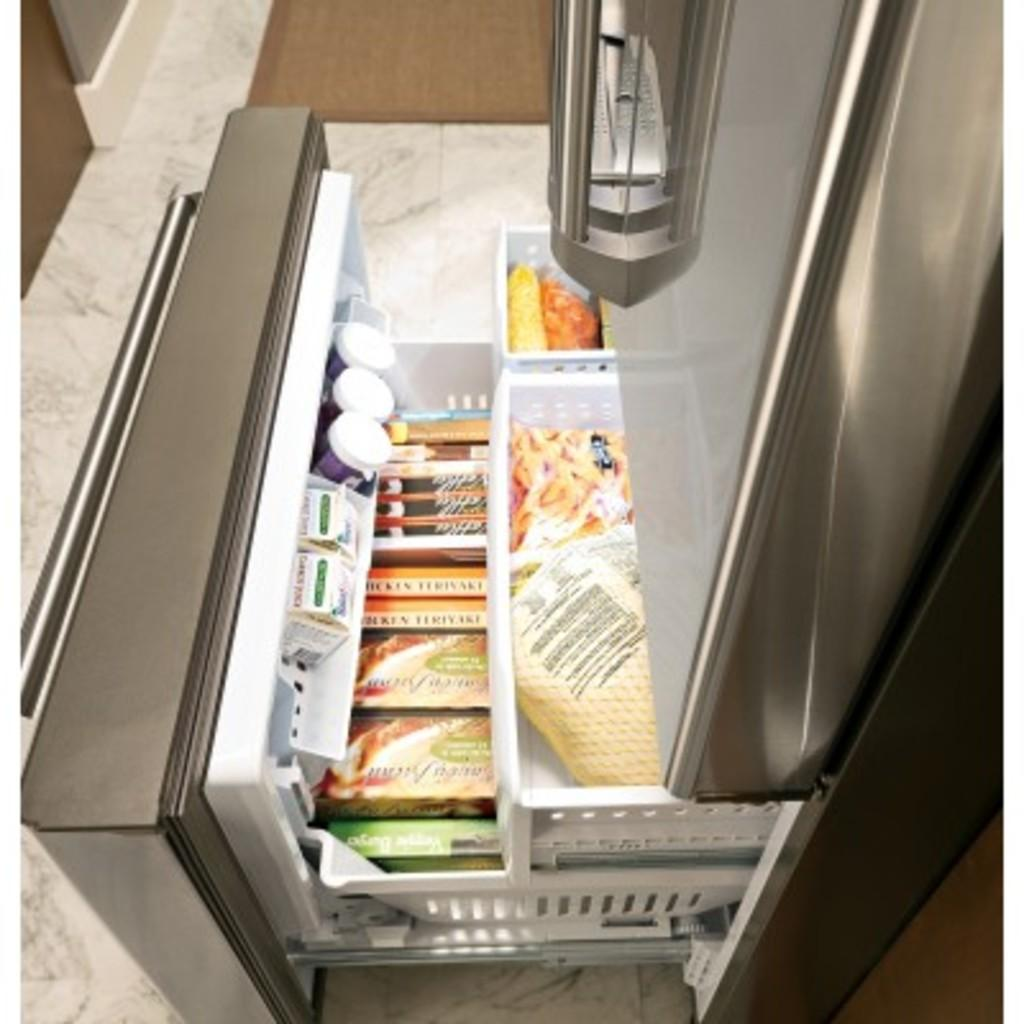What type of items can be seen in the image? There are food items in the image. Where are the food items located? The food items are placed in a refrigerator. What type of ship is depicted in the image? There is no ship present in the image; it features food items in a refrigerator. What emotion can be seen on the face of the ice in the image? There is no ice or face in the image; it only contains food items in a refrigerator. 